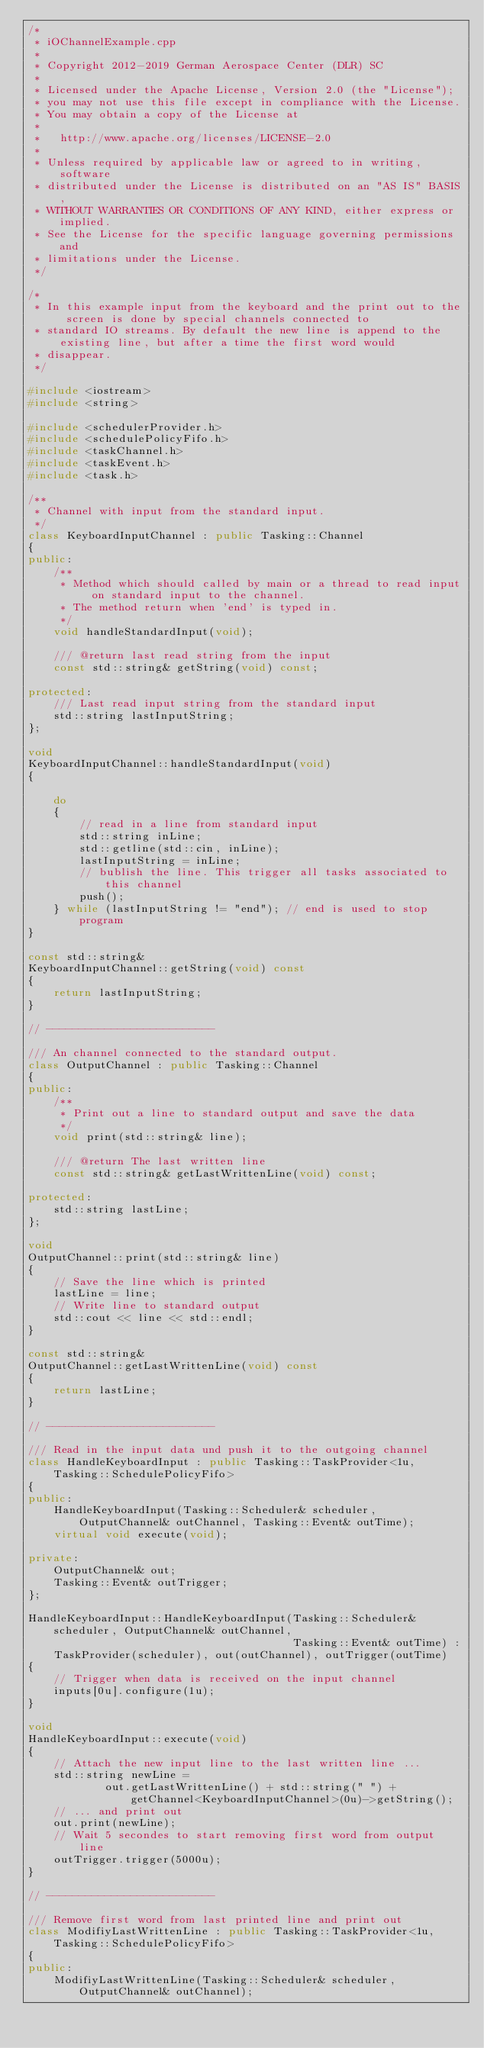<code> <loc_0><loc_0><loc_500><loc_500><_C++_>/*
 * iOChannelExample.cpp
 *
 * Copyright 2012-2019 German Aerospace Center (DLR) SC
 *
 * Licensed under the Apache License, Version 2.0 (the "License");
 * you may not use this file except in compliance with the License.
 * You may obtain a copy of the License at
 *
 *   http://www.apache.org/licenses/LICENSE-2.0
 *
 * Unless required by applicable law or agreed to in writing, software
 * distributed under the License is distributed on an "AS IS" BASIS,
 * WITHOUT WARRANTIES OR CONDITIONS OF ANY KIND, either express or implied.
 * See the License for the specific language governing permissions and
 * limitations under the License.
 */

/*
 * In this example input from the keyboard and the print out to the screen is done by special channels connected to
 * standard IO streams. By default the new line is append to the existing line, but after a time the first word would
 * disappear.
 */

#include <iostream>
#include <string>

#include <schedulerProvider.h>
#include <schedulePolicyFifo.h>
#include <taskChannel.h>
#include <taskEvent.h>
#include <task.h>

/**
 * Channel with input from the standard input.
 */
class KeyboardInputChannel : public Tasking::Channel
{
public:
    /**
     * Method which should called by main or a thread to read input on standard input to the channel.
     * The method return when 'end' is typed in.
     */
    void handleStandardInput(void);

    /// @return last read string from the input
    const std::string& getString(void) const;

protected:
    /// Last read input string from the standard input
    std::string lastInputString;
};

void
KeyboardInputChannel::handleStandardInput(void)
{

    do
    {
        // read in a line from standard input
        std::string inLine;
        std::getline(std::cin, inLine);
        lastInputString = inLine;
        // bublish the line. This trigger all tasks associated to this channel
        push();
    } while (lastInputString != "end"); // end is used to stop program
}

const std::string&
KeyboardInputChannel::getString(void) const
{
    return lastInputString;
}

// --------------------------

/// An channel connected to the standard output.
class OutputChannel : public Tasking::Channel
{
public:
    /**
     * Print out a line to standard output and save the data
     */
    void print(std::string& line);

    /// @return The last written line
    const std::string& getLastWrittenLine(void) const;

protected:
    std::string lastLine;
};

void
OutputChannel::print(std::string& line)
{
    // Save the line which is printed
    lastLine = line;
    // Write line to standard output
    std::cout << line << std::endl;
}

const std::string&
OutputChannel::getLastWrittenLine(void) const
{
    return lastLine;
}

// --------------------------

/// Read in the input data und push it to the outgoing channel
class HandleKeyboardInput : public Tasking::TaskProvider<1u, Tasking::SchedulePolicyFifo>
{
public:
    HandleKeyboardInput(Tasking::Scheduler& scheduler, OutputChannel& outChannel, Tasking::Event& outTime);
    virtual void execute(void);

private:
    OutputChannel& out;
    Tasking::Event& outTrigger;
};

HandleKeyboardInput::HandleKeyboardInput(Tasking::Scheduler& scheduler, OutputChannel& outChannel,
                                         Tasking::Event& outTime) :
    TaskProvider(scheduler), out(outChannel), outTrigger(outTime)
{
    // Trigger when data is received on the input channel
    inputs[0u].configure(1u);
}

void
HandleKeyboardInput::execute(void)
{
    // Attach the new input line to the last written line ...
    std::string newLine =
            out.getLastWrittenLine() + std::string(" ") + getChannel<KeyboardInputChannel>(0u)->getString();
    // ... and print out
    out.print(newLine);
    // Wait 5 secondes to start removing first word from output line
    outTrigger.trigger(5000u);
}

// --------------------------

/// Remove first word from last printed line and print out
class ModifiyLastWrittenLine : public Tasking::TaskProvider<1u, Tasking::SchedulePolicyFifo>
{
public:
    ModifiyLastWrittenLine(Tasking::Scheduler& scheduler, OutputChannel& outChannel);</code> 